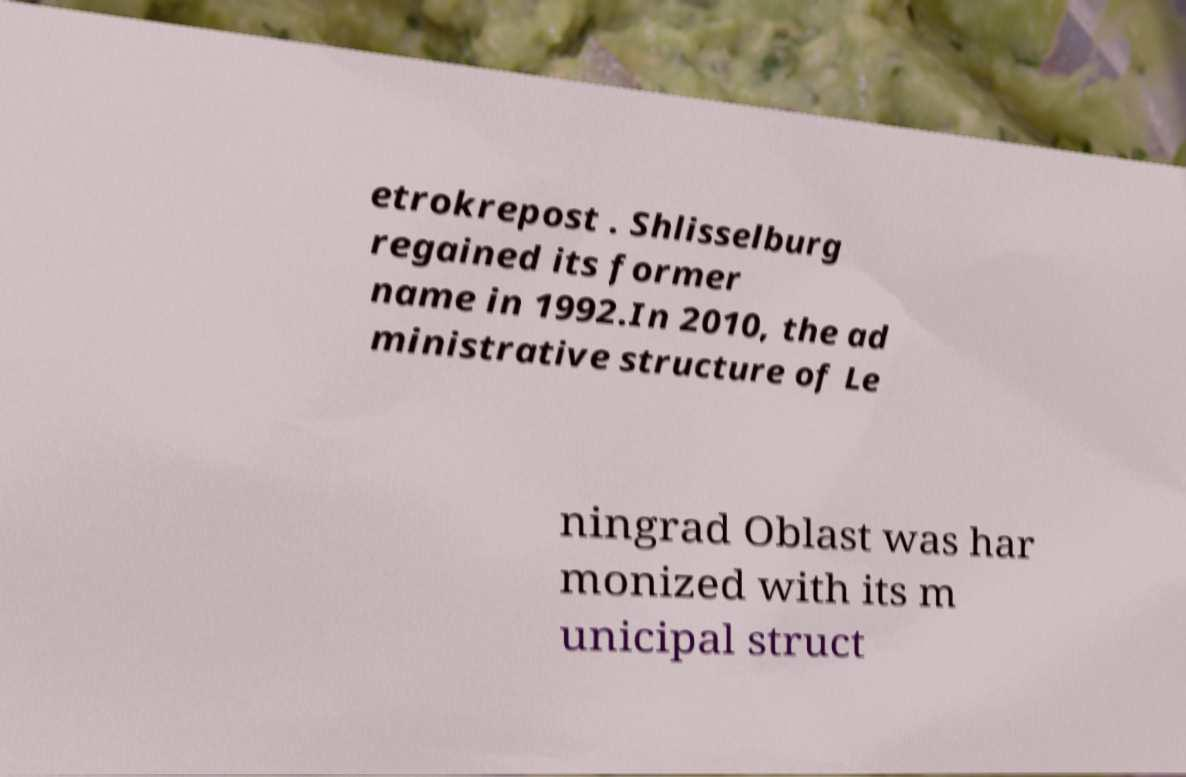Could you assist in decoding the text presented in this image and type it out clearly? etrokrepost . Shlisselburg regained its former name in 1992.In 2010, the ad ministrative structure of Le ningrad Oblast was har monized with its m unicipal struct 